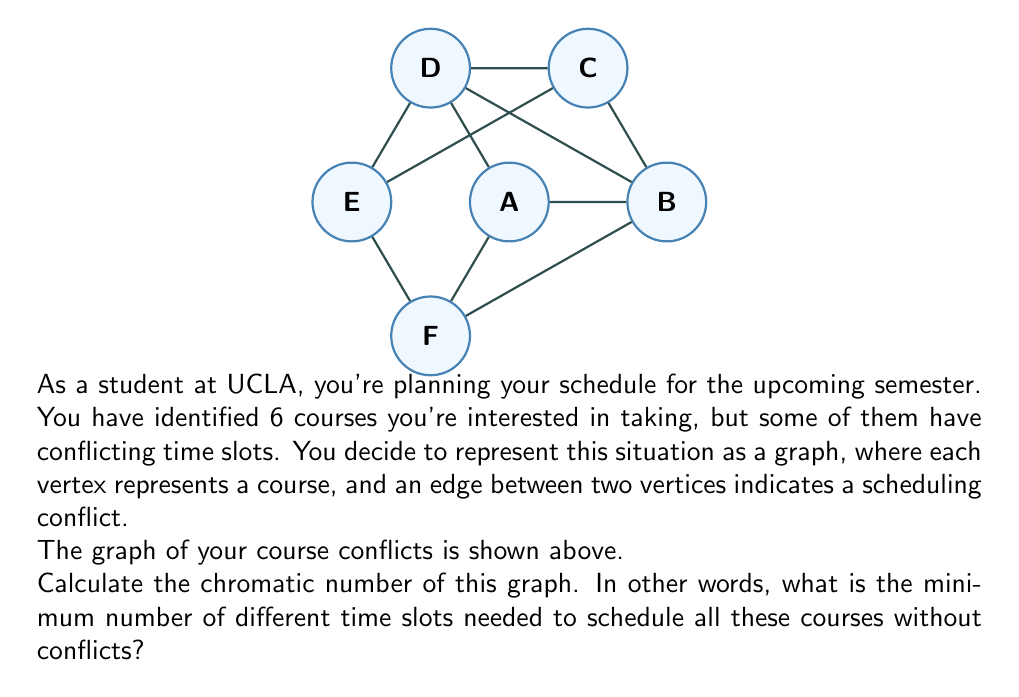Show me your answer to this math problem. To find the chromatic number of the graph, we need to determine the minimum number of colors required to color all vertices such that no two adjacent vertices have the same color. This is equivalent to finding the minimum number of time slots needed to schedule all courses without conflicts.

Let's approach this step-by-step:

1) First, note that the graph contains a cycle of length 5 (A-B-C-D-E-A). A cycle of odd length requires at least 3 colors.

2) Let's try to color the graph with 3 colors:
   - Assign color 1 to vertex A
   - Assign color 2 to vertices B and E
   - Assign color 3 to vertices C and D

3) Now we're left with vertex F. Let's check its connections:
   - F is connected to A (color 1)
   - F is connected to B (color 2)
   - F is connected to E (color 2)

4) We can't use colors 1 or 2 for F, but we can use color 3. The final coloring looks like this:
   - Color 1: A
   - Color 2: B, E
   - Color 3: C, D, F

5) We've successfully colored the graph using 3 colors, and it's impossible to do it with fewer colors due to the odd cycle.

Therefore, the chromatic number of this graph is 3.

In terms of course scheduling, this means you need a minimum of 3 different time slots to schedule all 6 courses without conflicts.
Answer: $$\chi(G) = 3$$ 